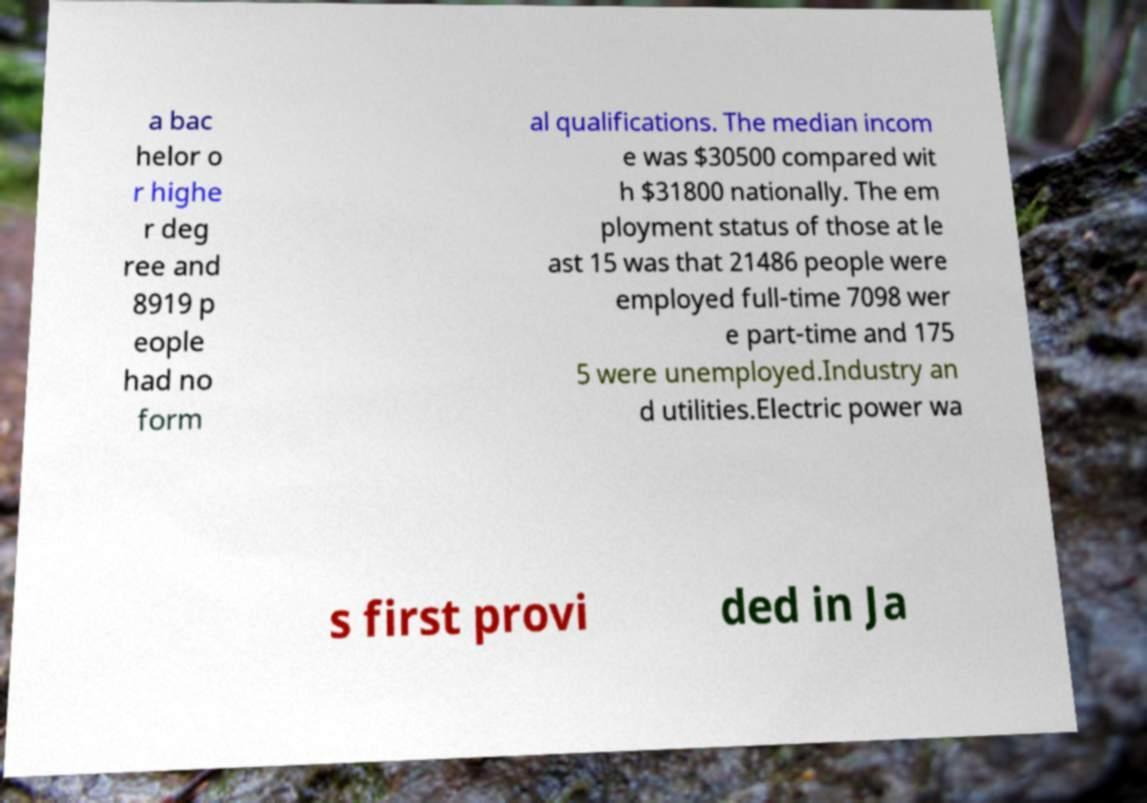I need the written content from this picture converted into text. Can you do that? a bac helor o r highe r deg ree and 8919 p eople had no form al qualifications. The median incom e was $30500 compared wit h $31800 nationally. The em ployment status of those at le ast 15 was that 21486 people were employed full-time 7098 wer e part-time and 175 5 were unemployed.Industry an d utilities.Electric power wa s first provi ded in Ja 